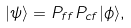Convert formula to latex. <formula><loc_0><loc_0><loc_500><loc_500>| \psi \rangle = P _ { f f } P _ { c f } | \phi \rangle ,</formula> 